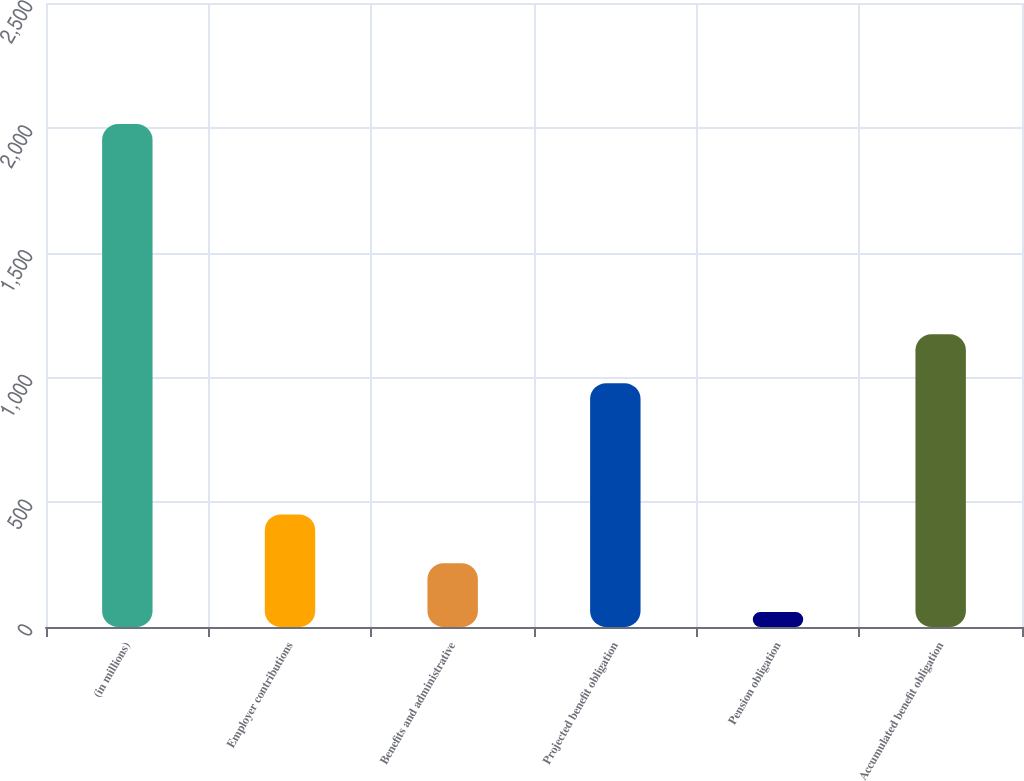<chart> <loc_0><loc_0><loc_500><loc_500><bar_chart><fcel>(in millions)<fcel>Employer contributions<fcel>Benefits and administrative<fcel>Projected benefit obligation<fcel>Pension obligation<fcel>Accumulated benefit obligation<nl><fcel>2015<fcel>451<fcel>255.5<fcel>977<fcel>60<fcel>1172.5<nl></chart> 